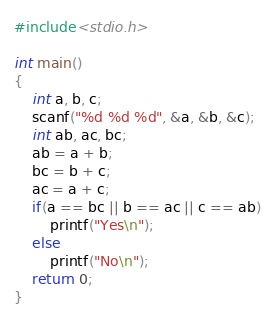<code> <loc_0><loc_0><loc_500><loc_500><_C_>#include<stdio.h>

int main()
{
	int a, b, c;
	scanf("%d %d %d", &a, &b, &c);
	int ab, ac, bc;
	ab = a + b;
	bc = b + c;
	ac = a + c;
	if(a == bc || b == ac || c == ab)
		printf("Yes\n");
	else
		printf("No\n");
	return 0;
}</code> 